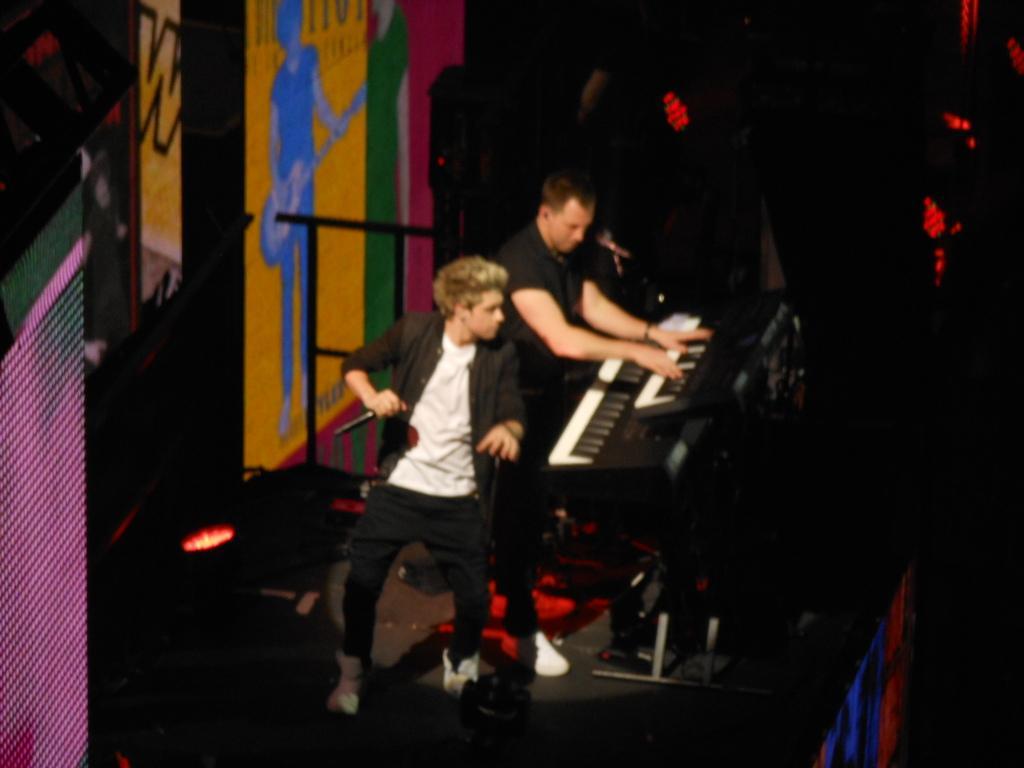How would you summarize this image in a sentence or two? In this image a person is standing and he is holding a mike in his hand. Behind him there is a person playing piano. Left side there is a wall having painting on it. A light is on the stage. 